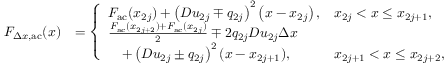Convert formula to latex. <formula><loc_0><loc_0><loc_500><loc_500>\begin{array} { r l } { F _ { \Delta x , a c } ( x ) } & { = \left \{ \begin{array} { l l } { F _ { a c } ( x _ { 2 j } ) + \left ( D u _ { 2 j } \mp q _ { 2 j } \right ) ^ { 2 } \left ( x - x _ { 2 j } \right ) , } & { x _ { 2 j } < x \leq x _ { 2 j + 1 } , } \\ { \frac { F _ { a c } ( x _ { 2 j + 2 } ) + F _ { a c } ( x _ { 2 j } ) } { 2 } \mp 2 q _ { 2 j } D u _ { 2 j } \Delta x } \\ { \quad + \left ( D u _ { 2 j } \pm q _ { 2 j } \right ) ^ { 2 } ( x - x _ { 2 j + 1 } ) , } & { x _ { 2 j + 1 } < x \leq x _ { 2 j + 2 } , } \end{array} } \end{array}</formula> 